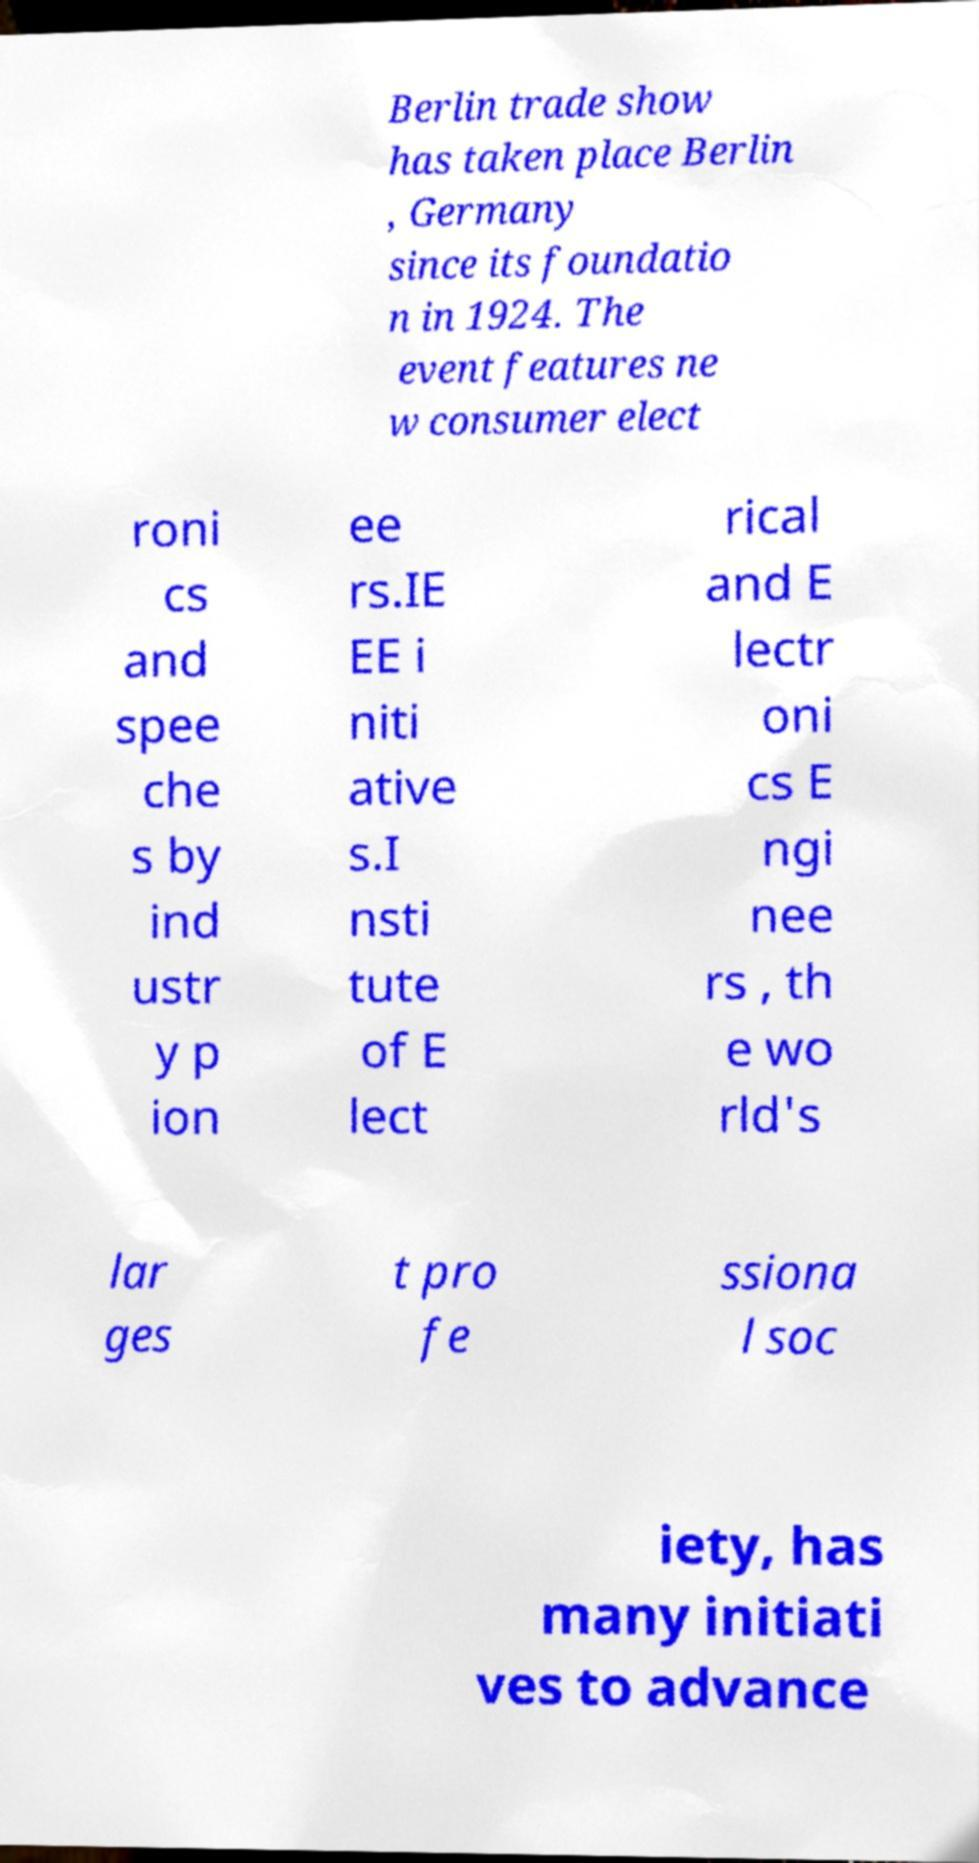Please read and relay the text visible in this image. What does it say? Berlin trade show has taken place Berlin , Germany since its foundatio n in 1924. The event features ne w consumer elect roni cs and spee che s by ind ustr y p ion ee rs.IE EE i niti ative s.I nsti tute of E lect rical and E lectr oni cs E ngi nee rs , th e wo rld's lar ges t pro fe ssiona l soc iety, has many initiati ves to advance 